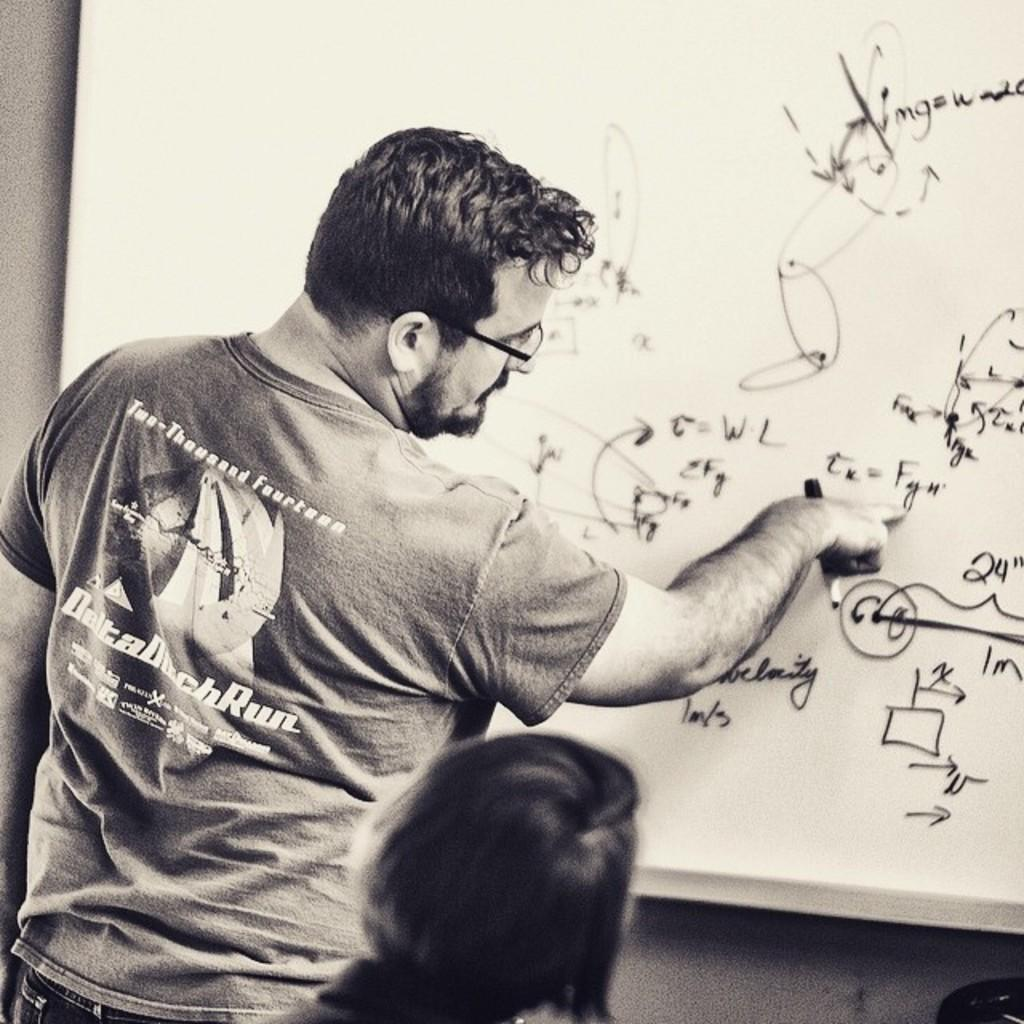<image>
Describe the image concisely. A man in a shirt with the word Run on it is writing on a white board. 